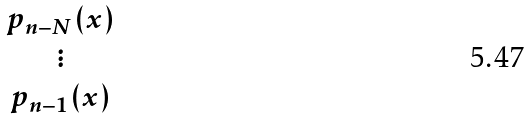<formula> <loc_0><loc_0><loc_500><loc_500>\begin{matrix} p _ { n - N } ( x ) \\ \vdots \\ p _ { n - 1 } ( x ) \end{matrix}</formula> 